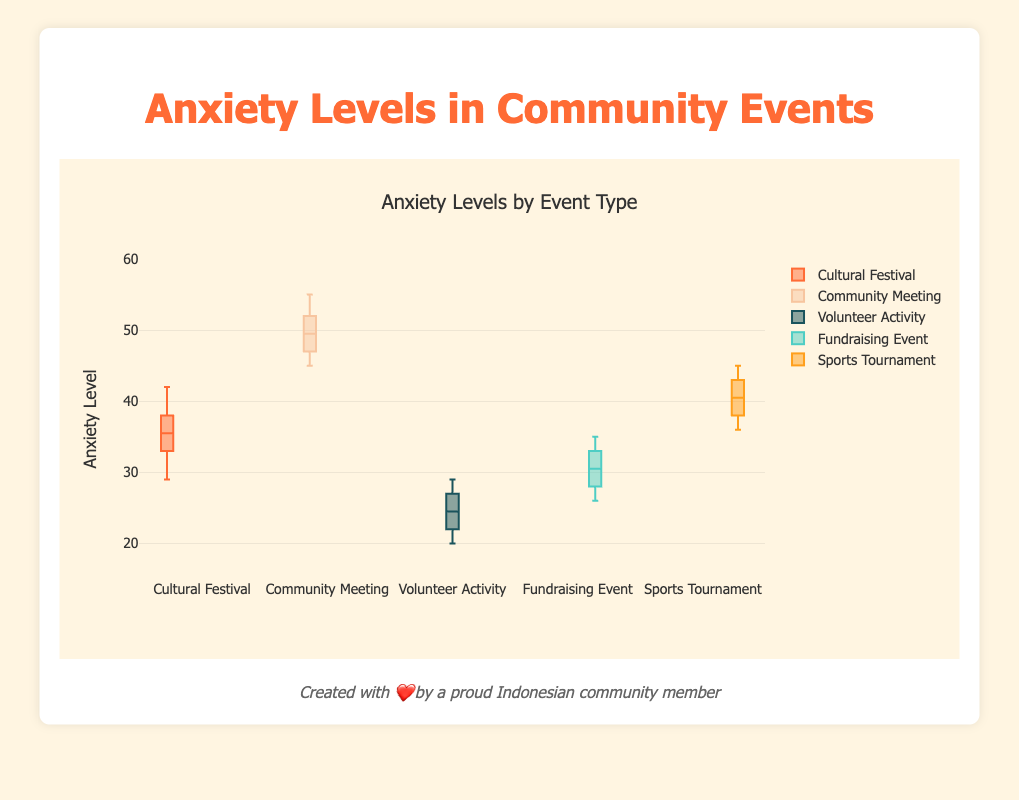What is the title of the plot? The title of the plot is prominently displayed at the top and provides a concise summary of the data being visualized. Reading this text reveals the title.
Answer: Anxiety Levels by Event Type What is the median anxiety level for the Cultural Festival? To find the median, locate the middle value of the sorted anxiety levels (29, 31, 33, 34, 35, 36, 37, 38, 40, 42). Since there are 10 values, the median is the average of the 5th and 6th values, which are 35 and 36. (35 + 36)/2 = 35.5
Answer: 35.5 Which event type has the lowest median anxiety level? Inspect each box plot's median line, which is the middle line of the box. The lowest median line is in the box for the Volunteer Activity.
Answer: Volunteer Activity How do the anxiety levels at the Community Meeting vary compared to the Fundraising Event? Compare the spread of anxiety levels by looking at the length of the boxes and the range of whiskers. The Community Meeting has a wider range (45-55) compared to the Fundraising Event (26-35), indicating more variability.
Answer: Community Meeting has more variability What is the interquartile range (IQR) for the Sports Tournament? The IQR is calculated by subtracting the first quartile (Q1, the bottom of the box) from the third quartile (Q3, the top of the box). Q1 is 37, and Q3 is 43 for the Sports Tournament. So, the IQR = 43 - 37 = 6
Answer: 6 Which event type has the highest maximum anxiety level observed? Look at the highest point (upper whisker) in each box plot. The highest value among all is for the Community Meeting, which reaches 55.
Answer: Community Meeting What can be said about the anxiety levels at the Volunteer Activity compared to others? The range and median levels are lower for the Volunteer Activity than other events. The median is around 25, and values range from 20 to 29, indicating generally low anxiety levels.
Answer: Lower anxiety levels compared to others What is the median anxiety level of the Fundraising Event? Identify the middle value from the arranged list (26, 27, 28, 29, 30, 31, 32, 33, 34, 35). The median is the average of the 5th and 6th values: (30 + 31)/2 = 30.5
Answer: 30.5 